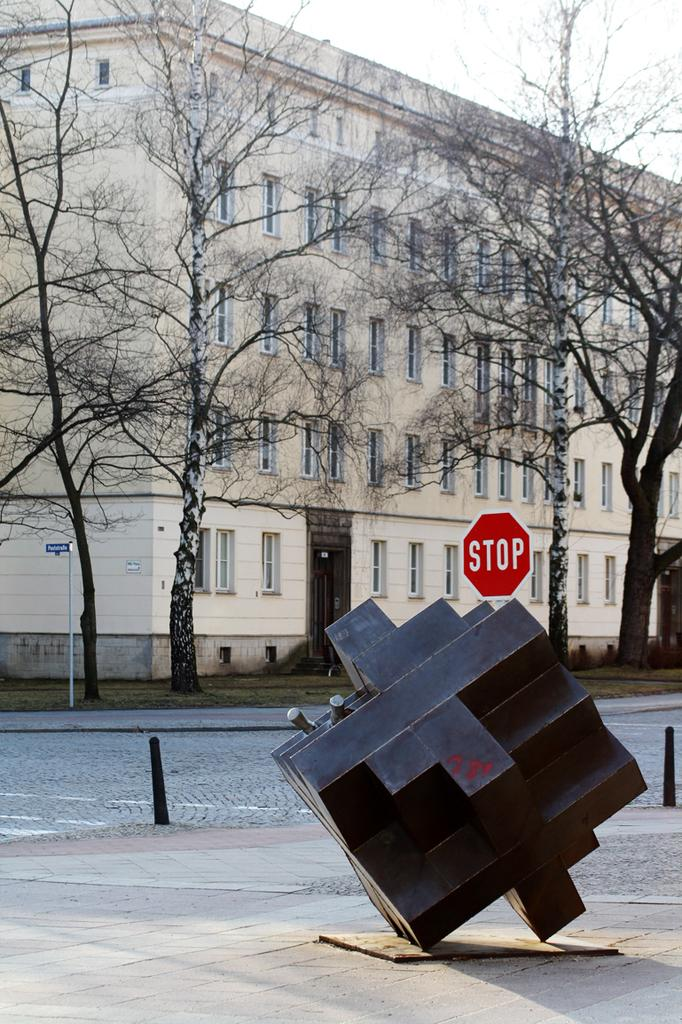What type of structure is visible in the image? There is a building with several windows in the image. What can be seen in the background of the image? There are trees in the image. What is the pathway used for in the image? The pathway is visible in the image, but its purpose is not specified. What are the poles used for in the image? The purpose of the poles in the image is not specified. What is the shape of the object in the image? There is a cube in the image. What is the board used for in the image? The purpose of the board in the image is not specified. What is visible in the sky in the image? The sky is visible in the image. What type of flame can be seen coming from the cube in the image? There is no flame present in the image; it features a cube and other elements as described in the facts. 